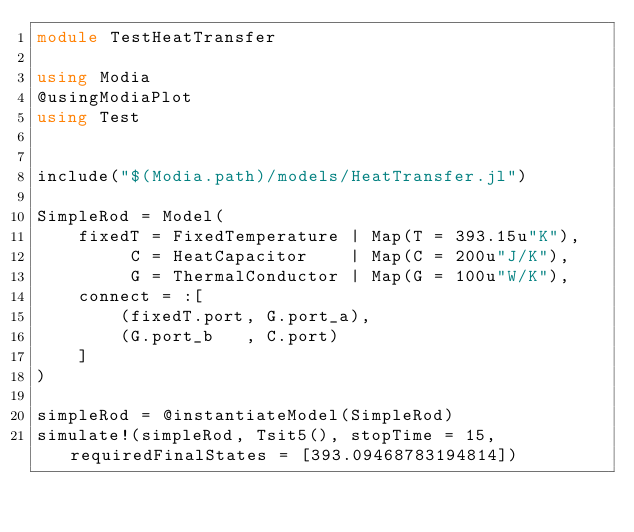Convert code to text. <code><loc_0><loc_0><loc_500><loc_500><_Julia_>module TestHeatTransfer

using Modia
@usingModiaPlot
using Test


include("$(Modia.path)/models/HeatTransfer.jl")

SimpleRod = Model(
    fixedT = FixedTemperature | Map(T = 393.15u"K"),
         C = HeatCapacitor    | Map(C = 200u"J/K"),
         G = ThermalConductor | Map(G = 100u"W/K"),
    connect = :[
        (fixedT.port, G.port_a),
        (G.port_b   , C.port)
    ]
)

simpleRod = @instantiateModel(SimpleRod)
simulate!(simpleRod, Tsit5(), stopTime = 15, requiredFinalStates = [393.09468783194814])</code> 